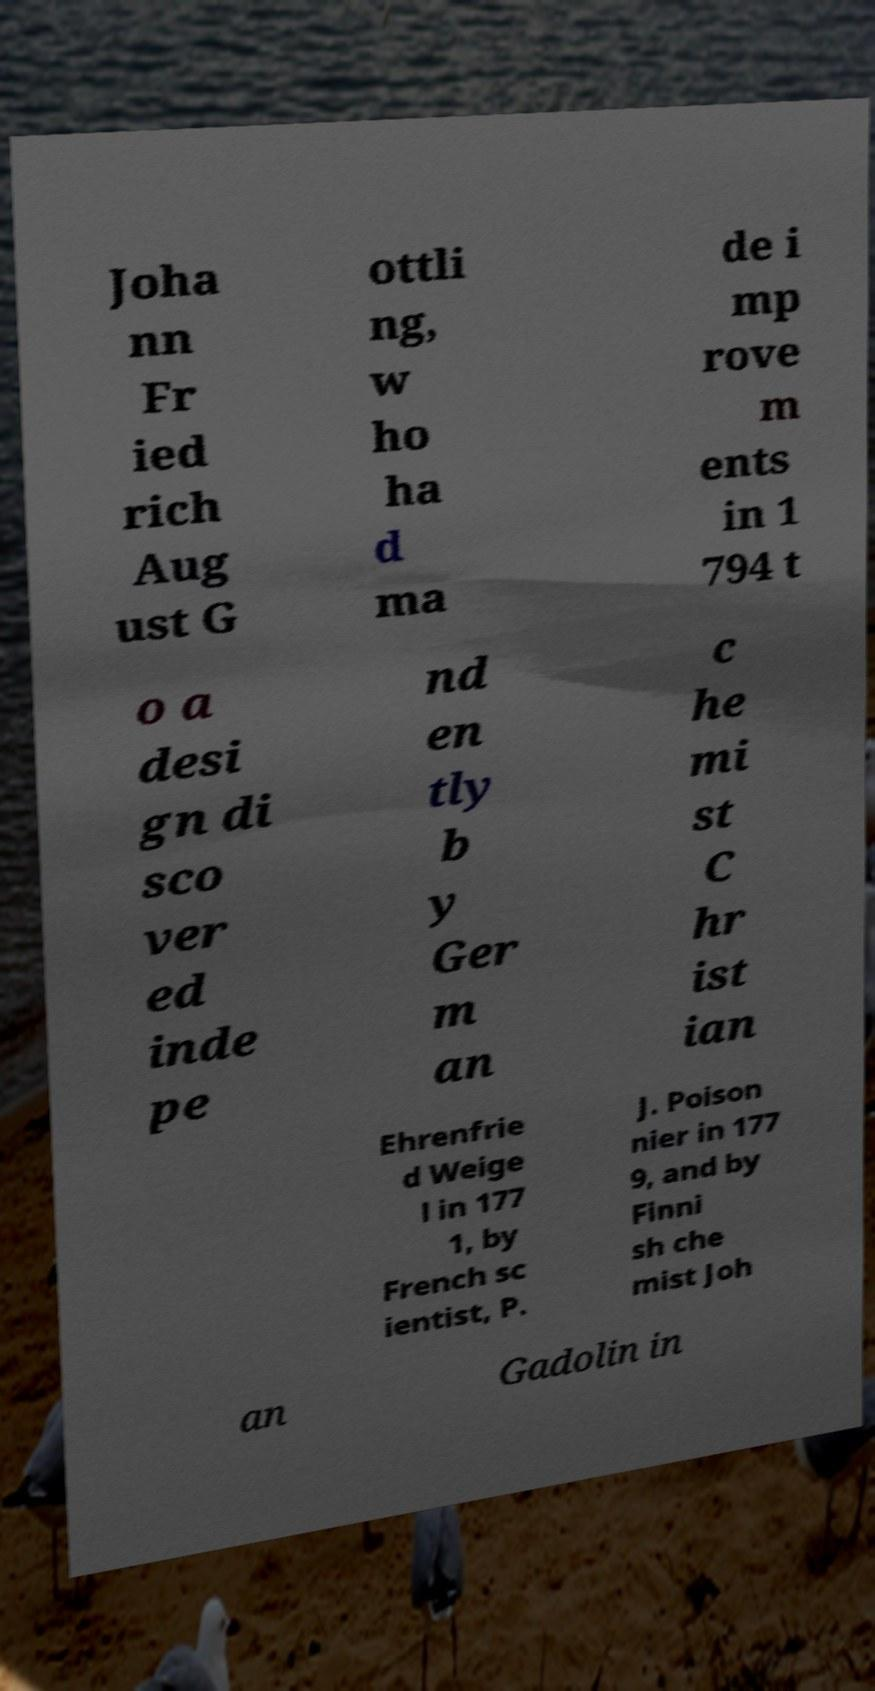I need the written content from this picture converted into text. Can you do that? Joha nn Fr ied rich Aug ust G ottli ng, w ho ha d ma de i mp rove m ents in 1 794 t o a desi gn di sco ver ed inde pe nd en tly b y Ger m an c he mi st C hr ist ian Ehrenfrie d Weige l in 177 1, by French sc ientist, P. J. Poison nier in 177 9, and by Finni sh che mist Joh an Gadolin in 